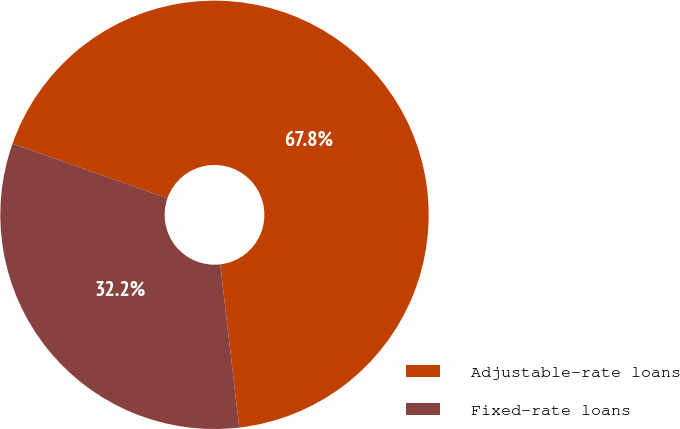<chart> <loc_0><loc_0><loc_500><loc_500><pie_chart><fcel>Adjustable-rate loans<fcel>Fixed-rate loans<nl><fcel>67.77%<fcel>32.23%<nl></chart> 